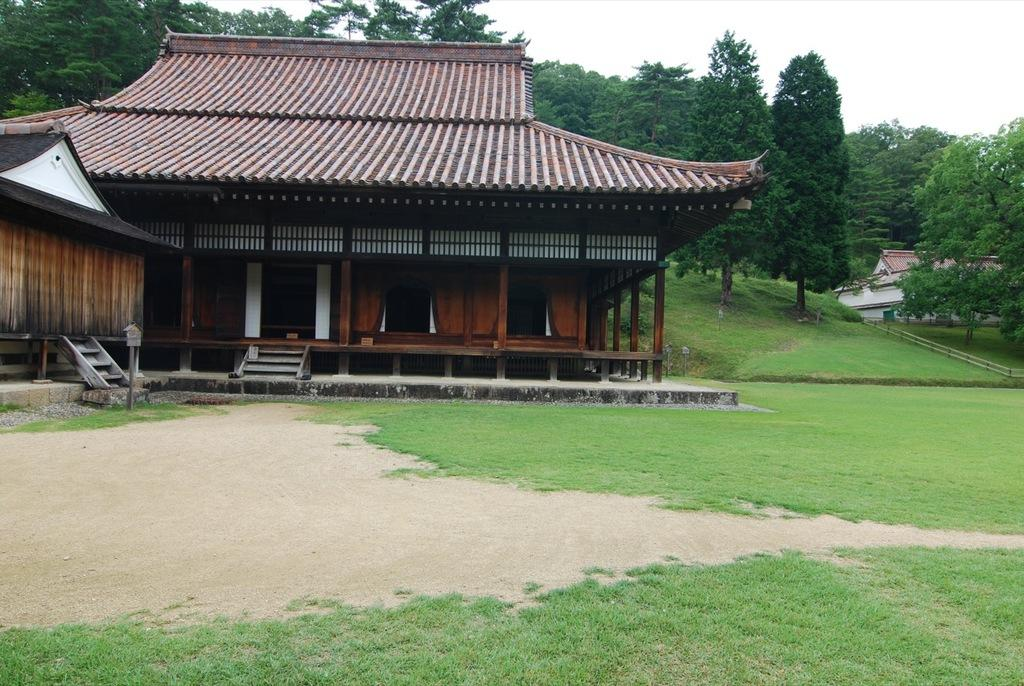What type of structures can be seen in the image? There are houses in the image. What architectural feature is present in the image? There are stairs in the image. What type of vegetation is visible in the image? There are trees and grass in the image. What type of barrier is present in the image? There is fencing in the image. What part of the natural environment is visible in the image? The sky is visible in the image. How many fifths are present in the image? There is no reference to a "fifth" in the image, so it is not possible to answer that question. What type of clocks can be seen in the image? There are no clocks present in the image. 